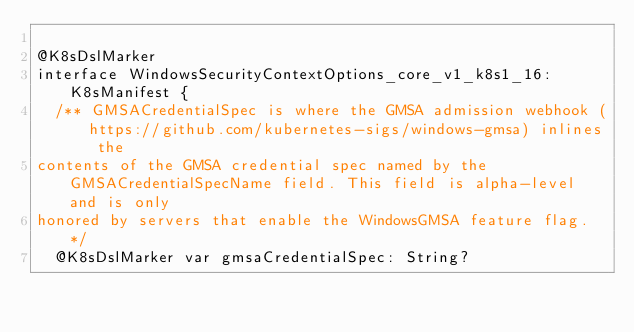Convert code to text. <code><loc_0><loc_0><loc_500><loc_500><_Kotlin_>      
@K8sDslMarker
interface WindowsSecurityContextOptions_core_v1_k8s1_16: K8sManifest {
  /** GMSACredentialSpec is where the GMSA admission webhook (https://github.com/kubernetes-sigs/windows-gmsa) inlines the
contents of the GMSA credential spec named by the GMSACredentialSpecName field. This field is alpha-level and is only
honored by servers that enable the WindowsGMSA feature flag. */
  @K8sDslMarker var gmsaCredentialSpec: String?</code> 